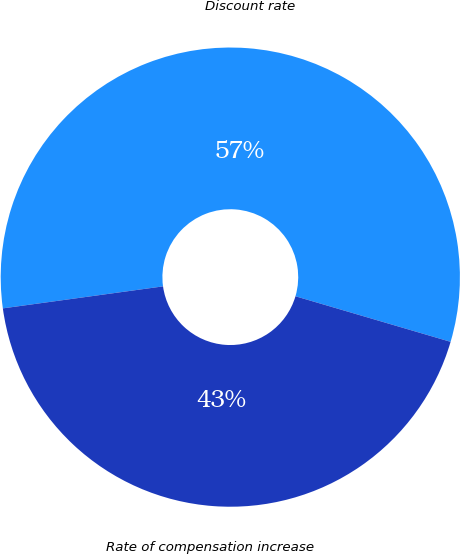Convert chart. <chart><loc_0><loc_0><loc_500><loc_500><pie_chart><fcel>Discount rate<fcel>Rate of compensation increase<nl><fcel>56.72%<fcel>43.28%<nl></chart> 